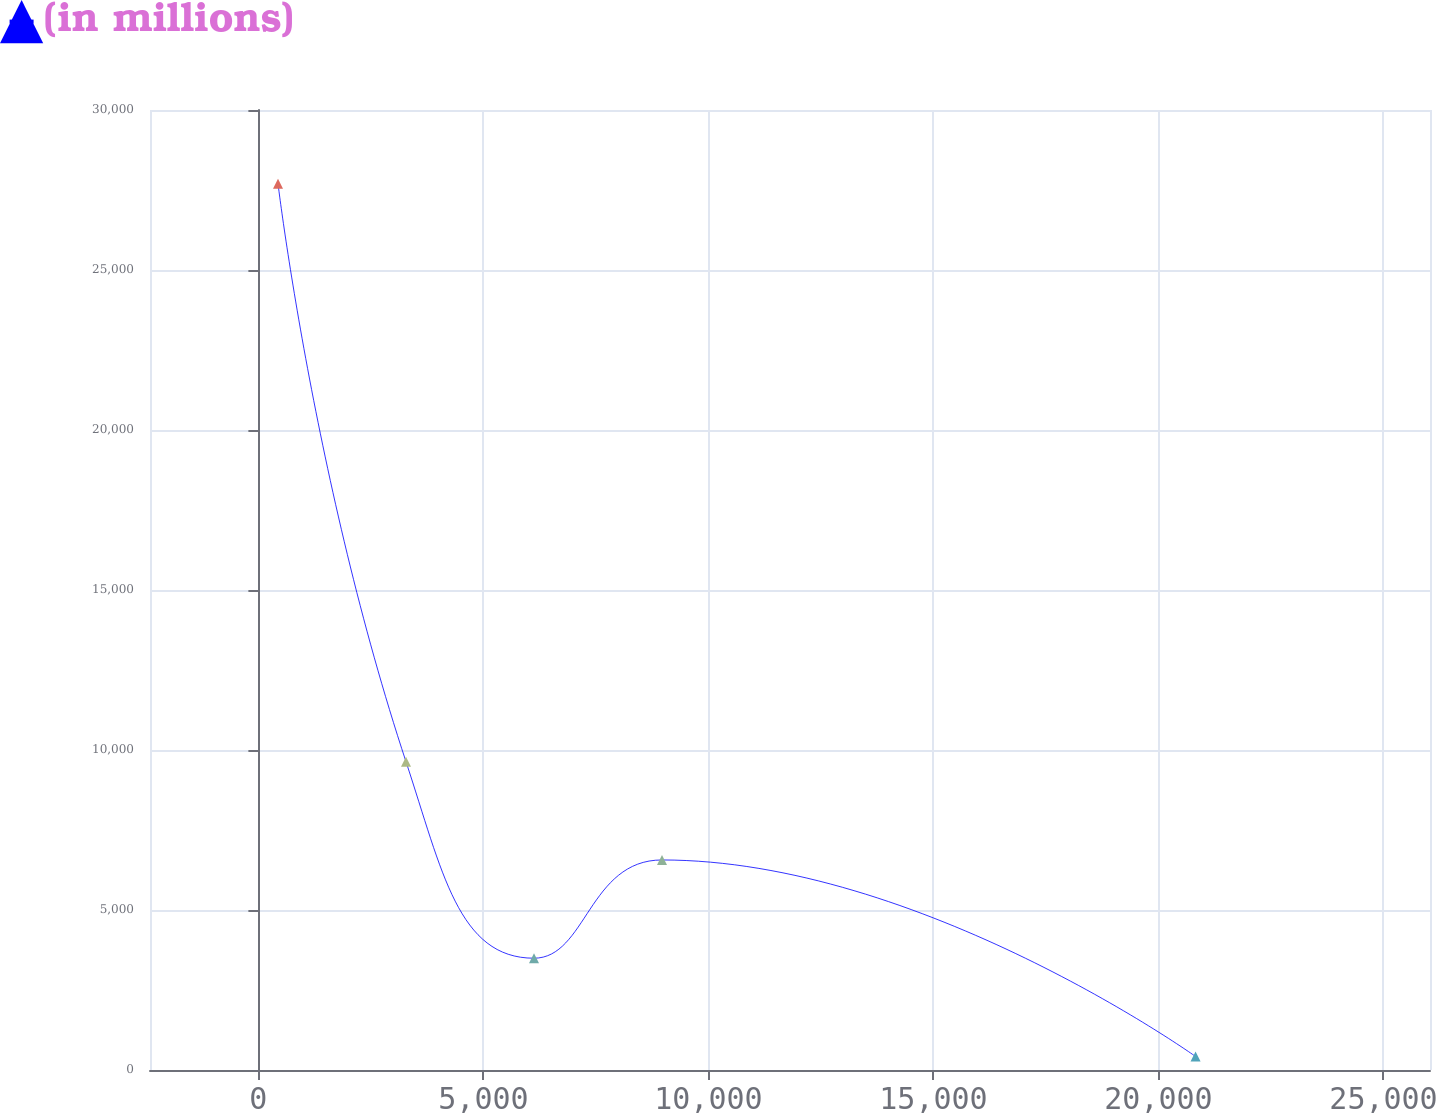Convert chart to OTSL. <chart><loc_0><loc_0><loc_500><loc_500><line_chart><ecel><fcel>(in millions)<nl><fcel>435.88<fcel>27699.2<nl><fcel>3280.03<fcel>9634.38<nl><fcel>6124.18<fcel>3493.5<nl><fcel>8968.33<fcel>6563.94<nl><fcel>20823.5<fcel>423.06<nl><fcel>28877.4<fcel>31127.5<nl></chart> 